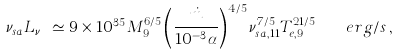Convert formula to latex. <formula><loc_0><loc_0><loc_500><loc_500>\nu _ { s a } L _ { \nu _ { s a } } \simeq 9 \times 1 0 ^ { 3 5 } M _ { 9 } ^ { 6 / 5 } \left ( \frac { \dot { m } } { 1 0 ^ { - 3 } \alpha } \right ) ^ { 4 / 5 } \nu _ { s a , 1 1 } ^ { 7 / 5 } T _ { e , 9 } ^ { 2 1 / 5 } \quad e r g / s \, ,</formula> 